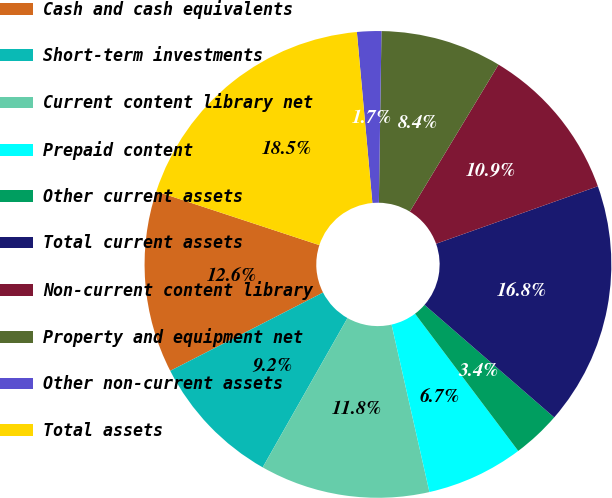<chart> <loc_0><loc_0><loc_500><loc_500><pie_chart><fcel>Cash and cash equivalents<fcel>Short-term investments<fcel>Current content library net<fcel>Prepaid content<fcel>Other current assets<fcel>Total current assets<fcel>Non-current content library<fcel>Property and equipment net<fcel>Other non-current assets<fcel>Total assets<nl><fcel>12.6%<fcel>9.24%<fcel>11.76%<fcel>6.72%<fcel>3.36%<fcel>16.81%<fcel>10.92%<fcel>8.4%<fcel>1.68%<fcel>18.49%<nl></chart> 